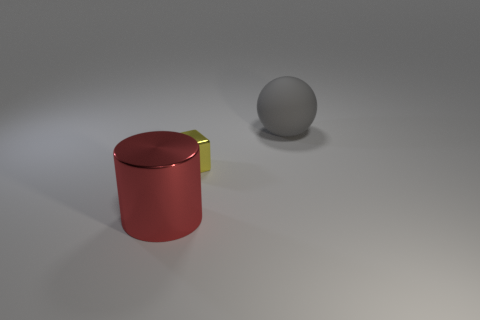There is a red object that is the same size as the gray matte ball; what material is it?
Give a very brief answer. Metal. What number of cylinders have the same color as the small metallic cube?
Provide a short and direct response. 0. There is a large sphere; are there any metallic cylinders behind it?
Provide a succinct answer. No. Do the large metal thing and the big thing right of the tiny shiny cube have the same shape?
Your response must be concise. No. What number of things are objects that are in front of the large gray sphere or cylinders?
Your answer should be very brief. 2. Are there any other things that have the same material as the ball?
Your response must be concise. No. What number of things are on the left side of the big gray ball and behind the large red shiny object?
Your answer should be very brief. 1. How many objects are either big objects that are in front of the metal block or big objects that are behind the cylinder?
Offer a very short reply. 2. How many other objects are there of the same shape as the big rubber object?
Make the answer very short. 0. How many other objects are the same size as the yellow cube?
Ensure brevity in your answer.  0. 